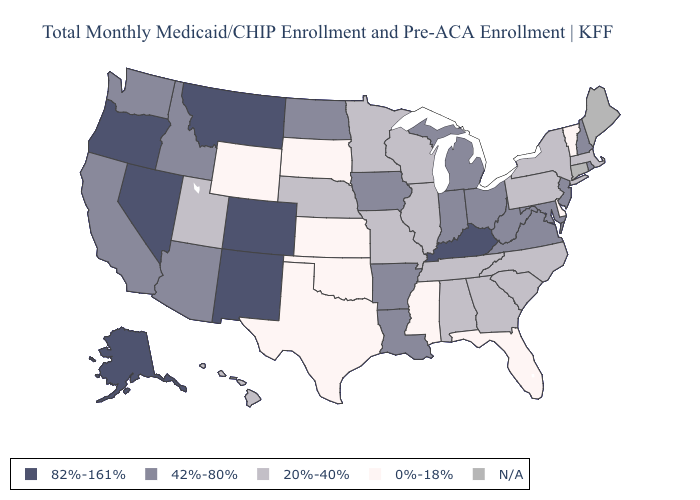What is the lowest value in the Northeast?
Be succinct. 0%-18%. Name the states that have a value in the range 42%-80%?
Write a very short answer. Arizona, Arkansas, California, Idaho, Indiana, Iowa, Louisiana, Maryland, Michigan, New Hampshire, New Jersey, North Dakota, Ohio, Rhode Island, Virginia, Washington, West Virginia. Among the states that border Texas , does Oklahoma have the highest value?
Give a very brief answer. No. Name the states that have a value in the range 82%-161%?
Write a very short answer. Alaska, Colorado, Kentucky, Montana, Nevada, New Mexico, Oregon. What is the highest value in states that border Washington?
Concise answer only. 82%-161%. Name the states that have a value in the range 82%-161%?
Answer briefly. Alaska, Colorado, Kentucky, Montana, Nevada, New Mexico, Oregon. Name the states that have a value in the range N/A?
Concise answer only. Connecticut, Maine. Name the states that have a value in the range 82%-161%?
Write a very short answer. Alaska, Colorado, Kentucky, Montana, Nevada, New Mexico, Oregon. Does the first symbol in the legend represent the smallest category?
Write a very short answer. No. Does the first symbol in the legend represent the smallest category?
Write a very short answer. No. What is the value of New York?
Keep it brief. 20%-40%. Name the states that have a value in the range 82%-161%?
Short answer required. Alaska, Colorado, Kentucky, Montana, Nevada, New Mexico, Oregon. Name the states that have a value in the range 82%-161%?
Concise answer only. Alaska, Colorado, Kentucky, Montana, Nevada, New Mexico, Oregon. Which states have the lowest value in the South?
Concise answer only. Delaware, Florida, Mississippi, Oklahoma, Texas. How many symbols are there in the legend?
Be succinct. 5. 